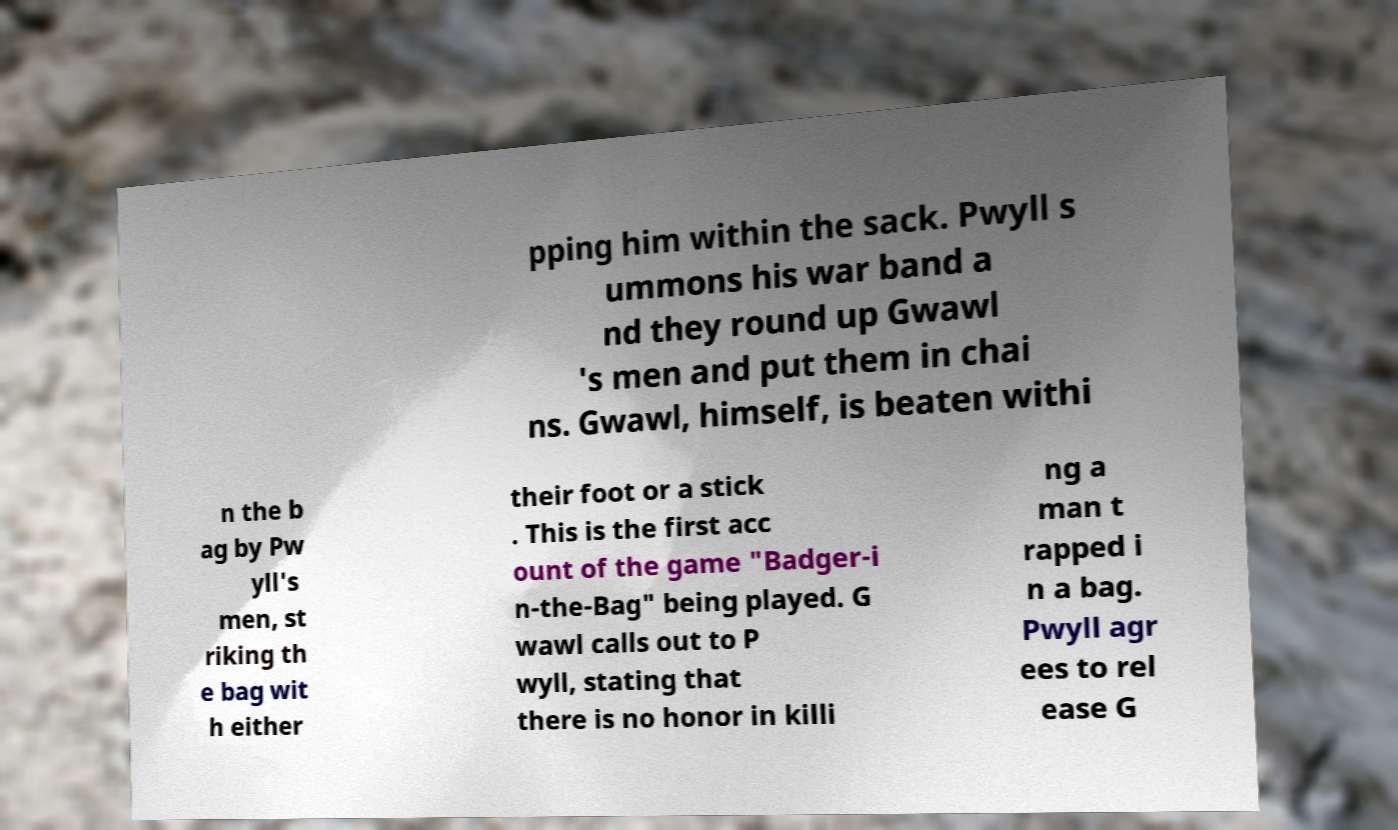Could you assist in decoding the text presented in this image and type it out clearly? pping him within the sack. Pwyll s ummons his war band a nd they round up Gwawl 's men and put them in chai ns. Gwawl, himself, is beaten withi n the b ag by Pw yll's men, st riking th e bag wit h either their foot or a stick . This is the first acc ount of the game "Badger-i n-the-Bag" being played. G wawl calls out to P wyll, stating that there is no honor in killi ng a man t rapped i n a bag. Pwyll agr ees to rel ease G 